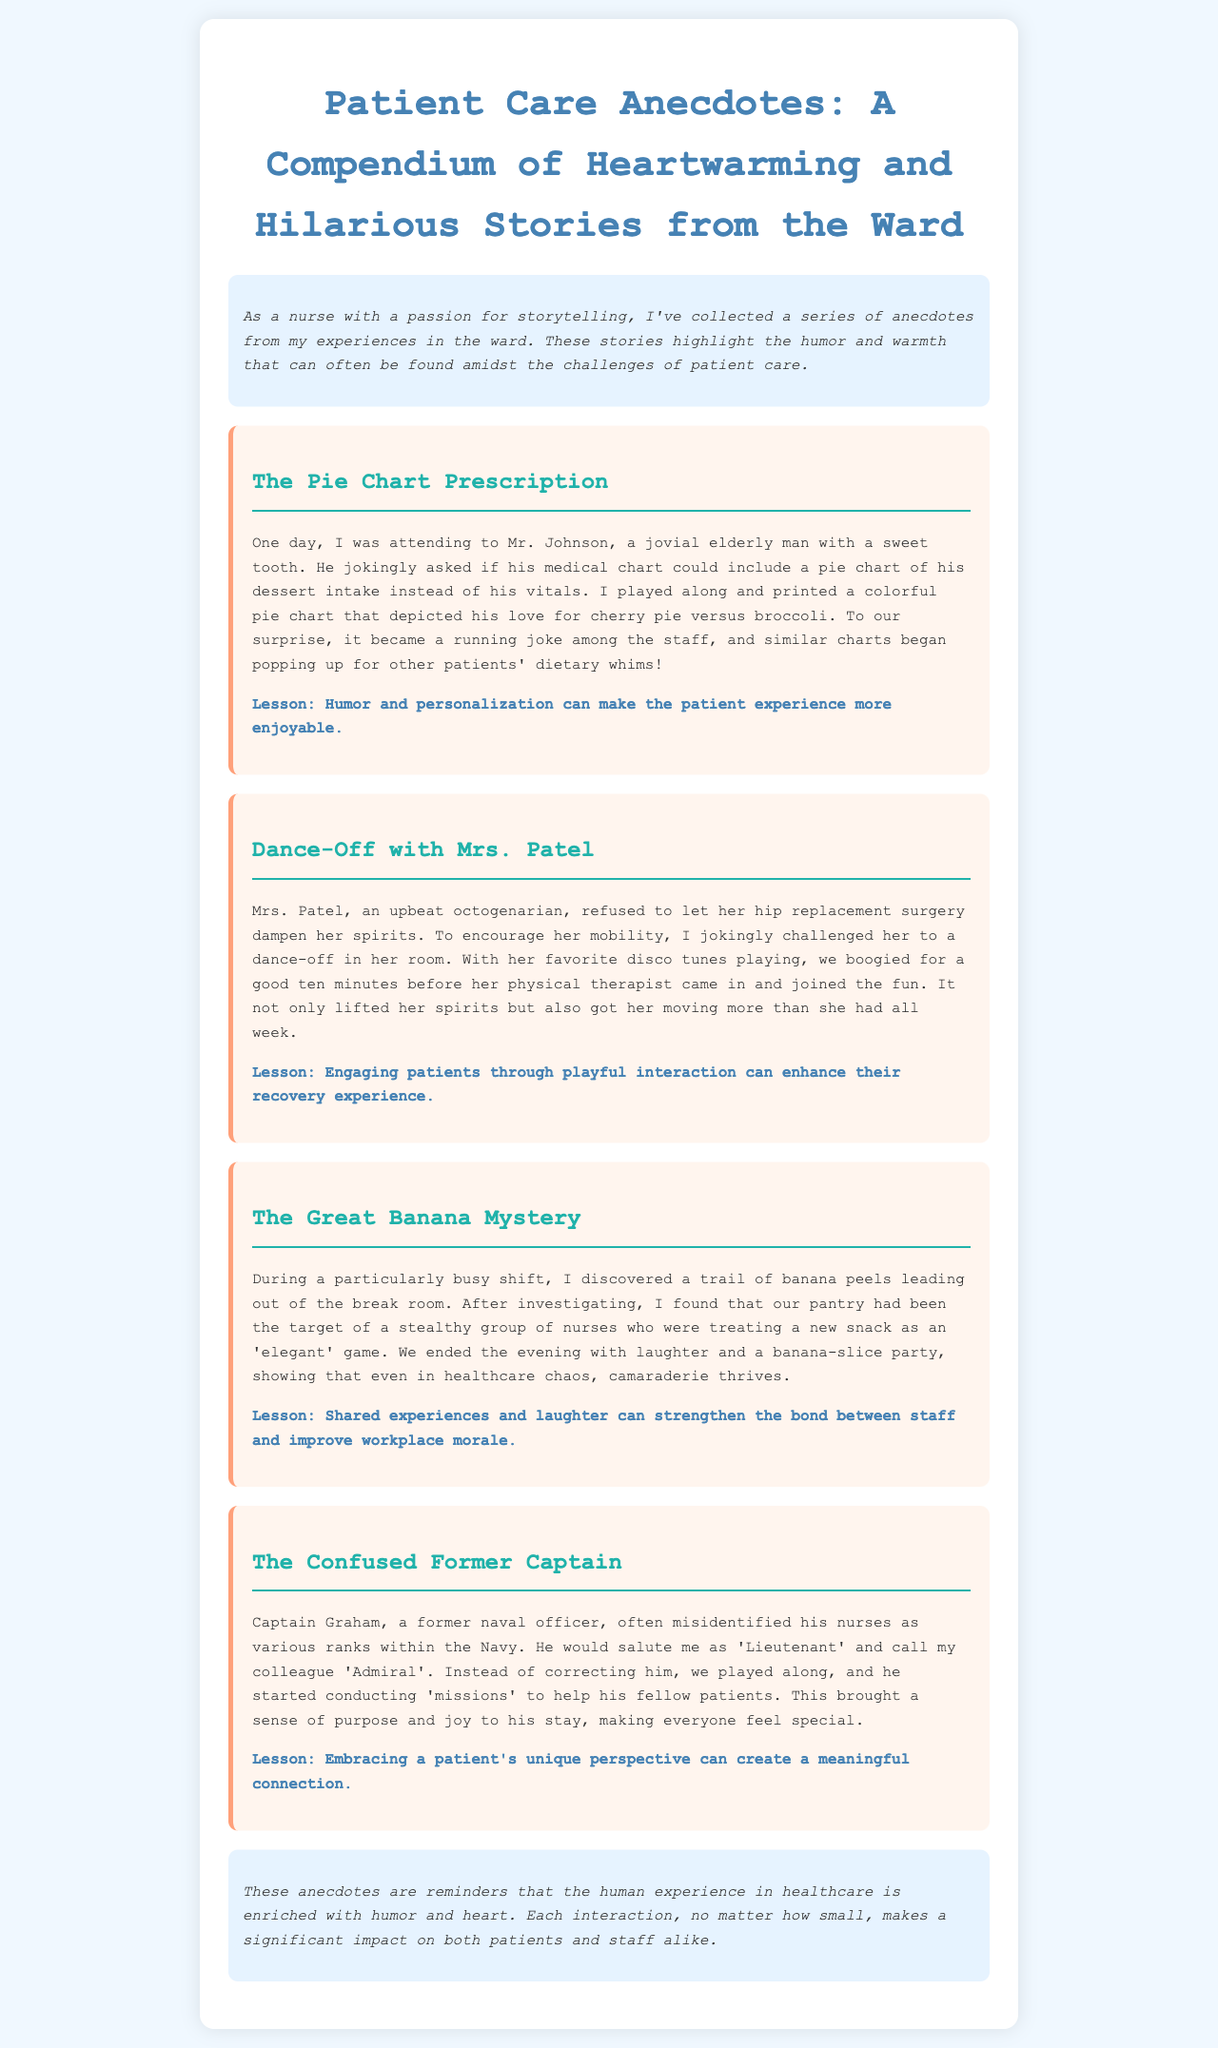What is the title of the document? The title is provided in the heading of the report, which gives the overall theme of the content.
Answer: Patient Care Anecdotes: A Compendium of Heartwarming and Hilarious Stories from the Ward Who is the author of the anecdotes? The introduction of the document mentions the author's profession and passion for storytelling.
Answer: A nurse How many anecdotes are shared in the document? The number of anecdotes can be counted from the sections presented under the main content.
Answer: Four What was Mr. Johnson's request regarding his medical chart? The anecdote details Mr. Johnson's humorous suggestion about his chart during the visit.
Answer: Pie chart of his dessert intake What lesson is derived from Mrs. Patel's story? Each anecdote ends with a lesson that summarizes the experience and insights gained.
Answer: Engaging patients through playful interaction can enhance their recovery experience What type of food did the staff use in the Great Banana Mystery? The anecdote focuses on the humorous scenario involving a specific type of food that sparked camaraderie among the staff.
Answer: Banana What unique labels did Captain Graham use for the nurses? The story highlights Captain Graham's entertaining misidentification of his caregivers by rank.
Answer: Ranks within the Navy What atmosphere do the anecdotes convey about the healthcare environment? The conclusion summarizes the overall tone and message of the anecdotes presented in the document.
Answer: Humor and heart What did the staff do during the banana-slice party? The anecdote illustrates the activities that ensued after the playful incident with banana peels.
Answer: Laughter and a banana-slice party 